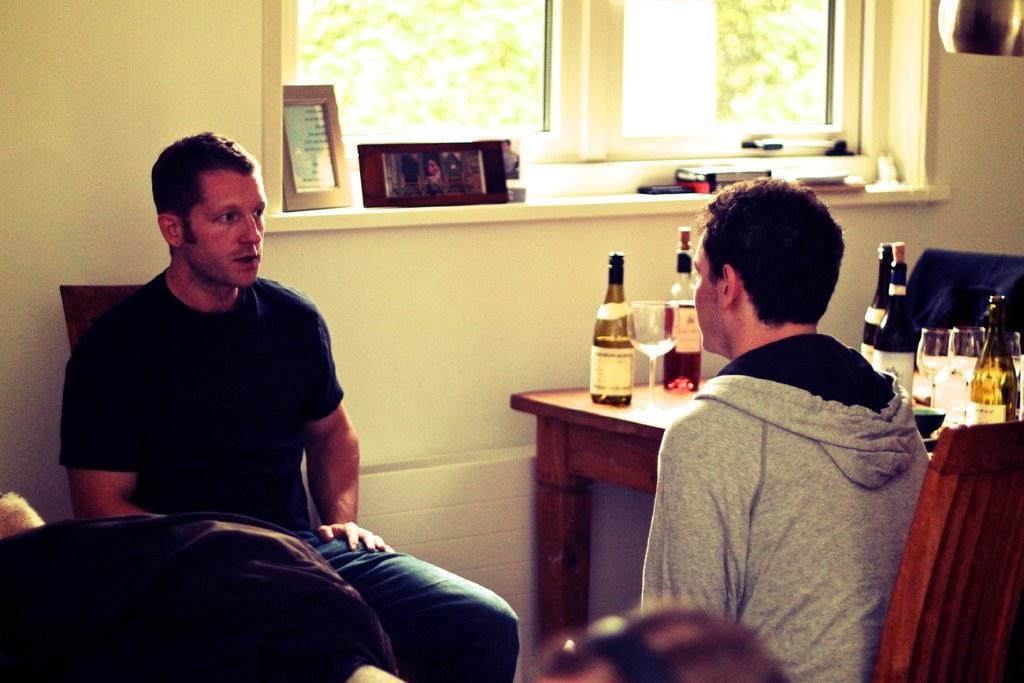Describe this image in one or two sentences. In this given image, We can see two people sitting in chairs after that couple of wine bottles which are kept on table and after that, We can see a window, few objects placed next, We can see a wall which is painted with a light cream color and few wine glasses behind the window, We can see trees. 